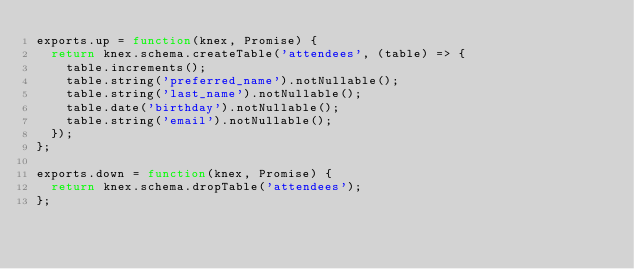Convert code to text. <code><loc_0><loc_0><loc_500><loc_500><_JavaScript_>exports.up = function(knex, Promise) {
  return knex.schema.createTable('attendees', (table) => {
    table.increments();
    table.string('preferred_name').notNullable();
    table.string('last_name').notNullable();
    table.date('birthday').notNullable();
    table.string('email').notNullable();
  });
};

exports.down = function(knex, Promise) {
  return knex.schema.dropTable('attendees');
};
</code> 